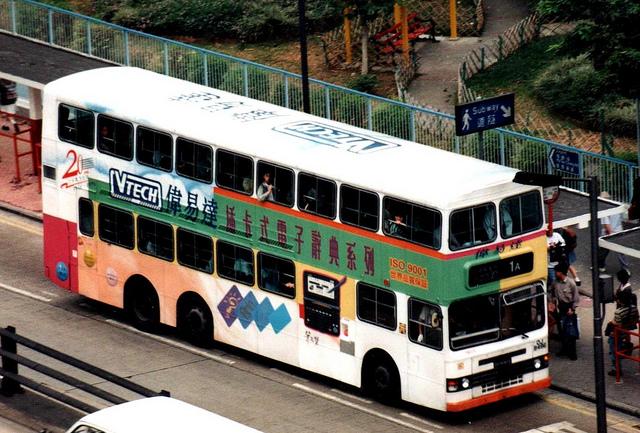What kind of vehicle is this?
Keep it brief. Bus. Is this in China?
Write a very short answer. Yes. What electronics company is listed on the side of the bus?
Give a very brief answer. Vtech. 